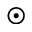Convert formula to latex. <formula><loc_0><loc_0><loc_500><loc_500>\odot</formula> 